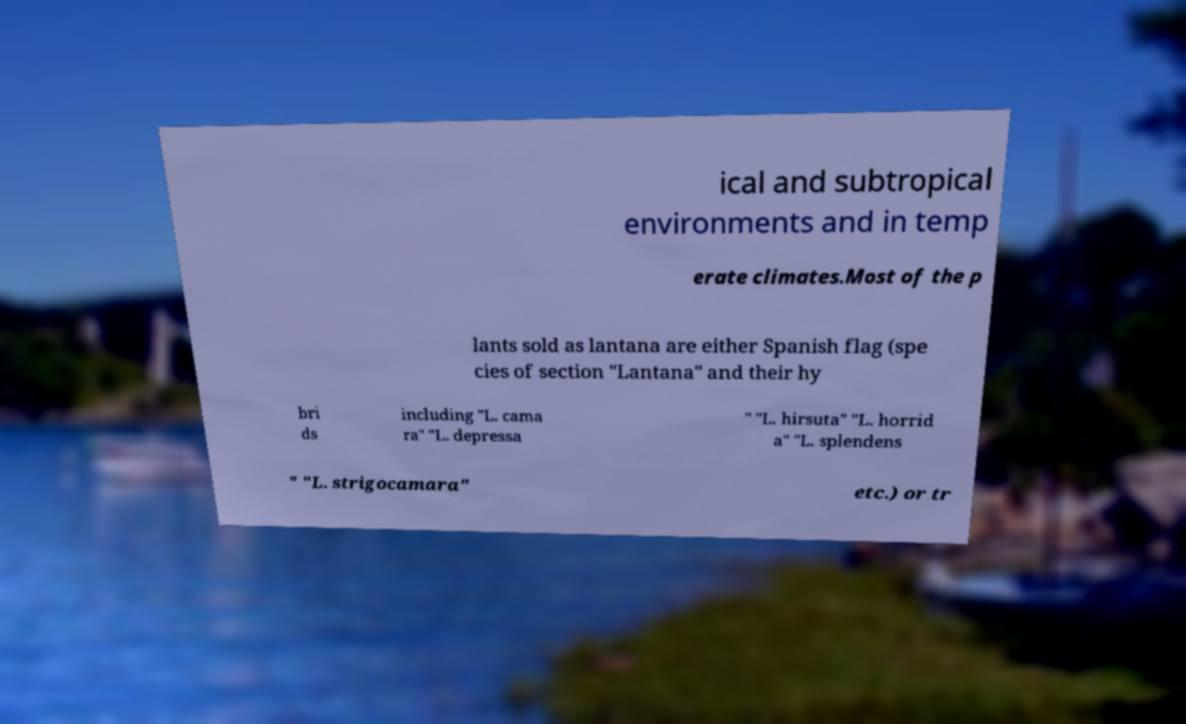For documentation purposes, I need the text within this image transcribed. Could you provide that? ical and subtropical environments and in temp erate climates.Most of the p lants sold as lantana are either Spanish flag (spe cies of section "Lantana" and their hy bri ds including "L. cama ra" "L. depressa " "L. hirsuta" "L. horrid a" "L. splendens " "L. strigocamara" etc.) or tr 